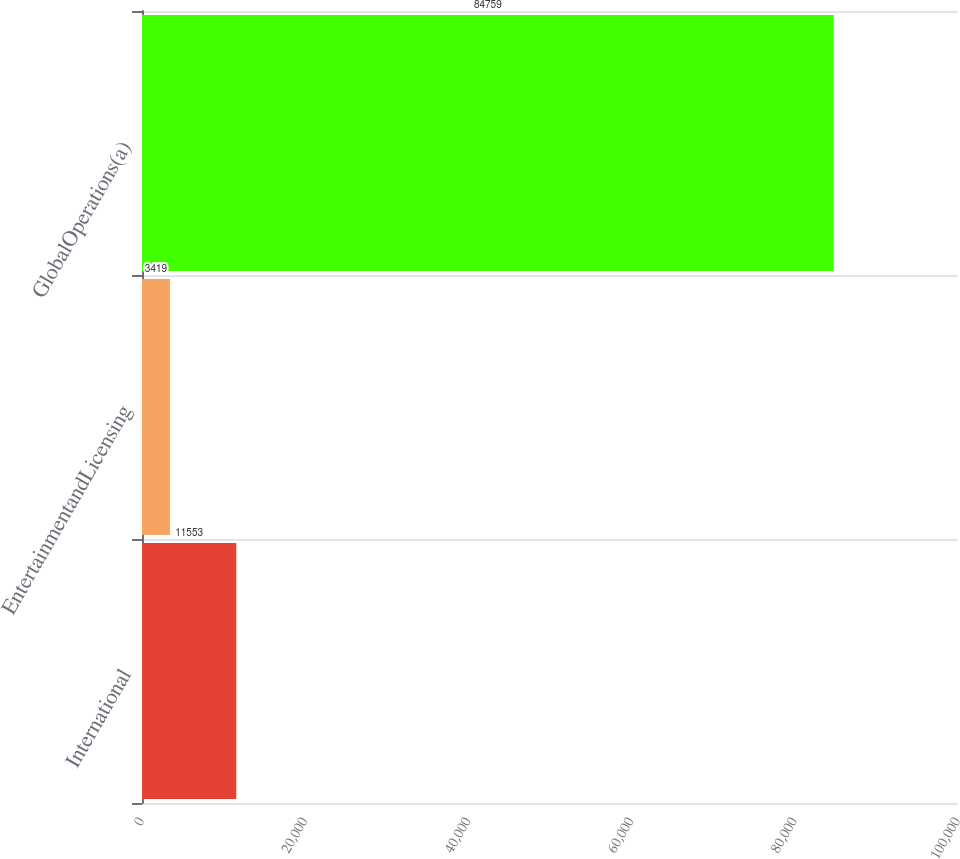Convert chart. <chart><loc_0><loc_0><loc_500><loc_500><bar_chart><fcel>International<fcel>EntertainmentandLicensing<fcel>GlobalOperations(a)<nl><fcel>11553<fcel>3419<fcel>84759<nl></chart> 